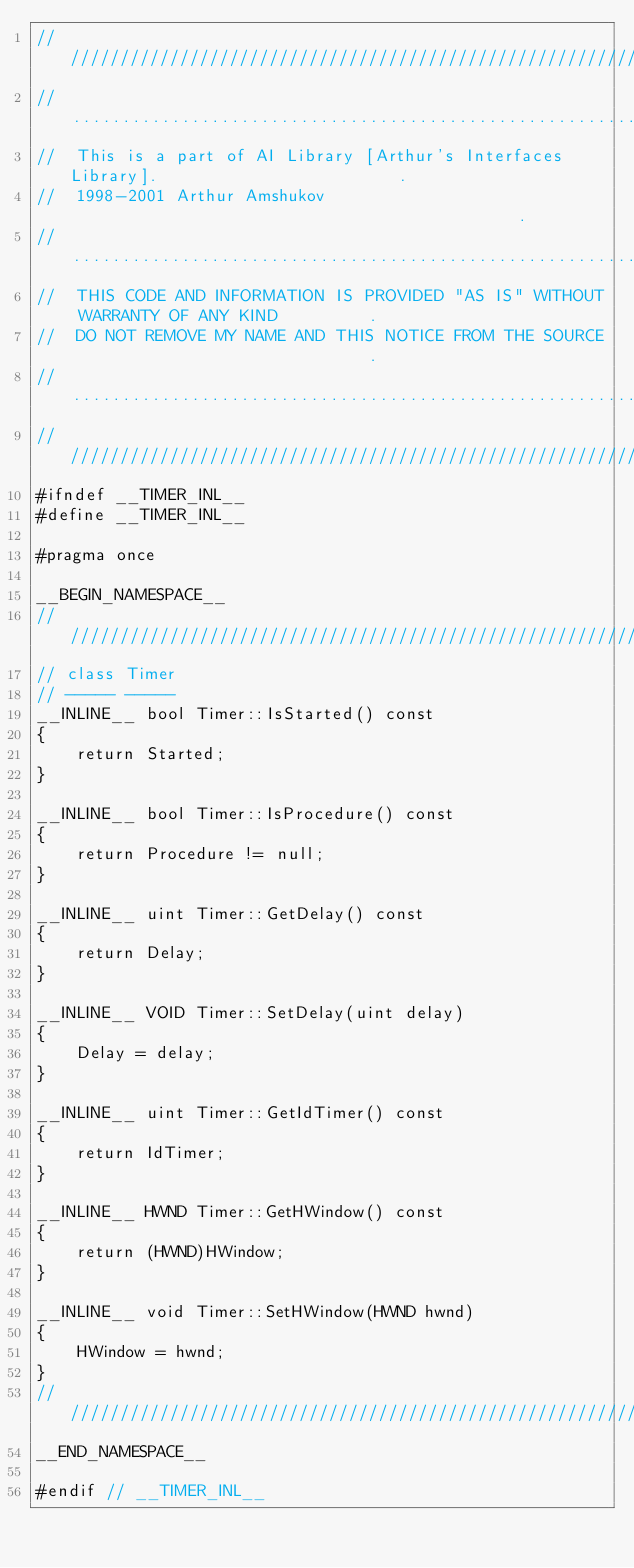<code> <loc_0><loc_0><loc_500><loc_500><_C++_>////////////////////////////////////////////////////////////////////////////////////////
//......................................................................................
//  This is a part of AI Library [Arthur's Interfaces Library].                        .
//  1998-2001 Arthur Amshukov                                              .
//......................................................................................
//  THIS CODE AND INFORMATION IS PROVIDED "AS IS" WITHOUT WARRANTY OF ANY KIND         .
//  DO NOT REMOVE MY NAME AND THIS NOTICE FROM THE SOURCE                              .
//......................................................................................
////////////////////////////////////////////////////////////////////////////////////////
#ifndef __TIMER_INL__
#define __TIMER_INL__

#pragma once

__BEGIN_NAMESPACE__
////////////////////////////////////////////////////////////////////////////////////////
// class Timer
// ----- -----
__INLINE__ bool Timer::IsStarted() const
{
    return Started;
}

__INLINE__ bool Timer::IsProcedure() const
{
    return Procedure != null;
}

__INLINE__ uint Timer::GetDelay() const
{
    return Delay;
}

__INLINE__ VOID Timer::SetDelay(uint delay)
{
    Delay = delay;
}

__INLINE__ uint Timer::GetIdTimer() const
{
    return IdTimer;
}

__INLINE__ HWND Timer::GetHWindow() const
{
    return (HWND)HWindow;
}

__INLINE__ void Timer::SetHWindow(HWND hwnd)
{
    HWindow = hwnd;
}
////////////////////////////////////////////////////////////////////////////////////////
__END_NAMESPACE__

#endif // __TIMER_INL__
</code> 